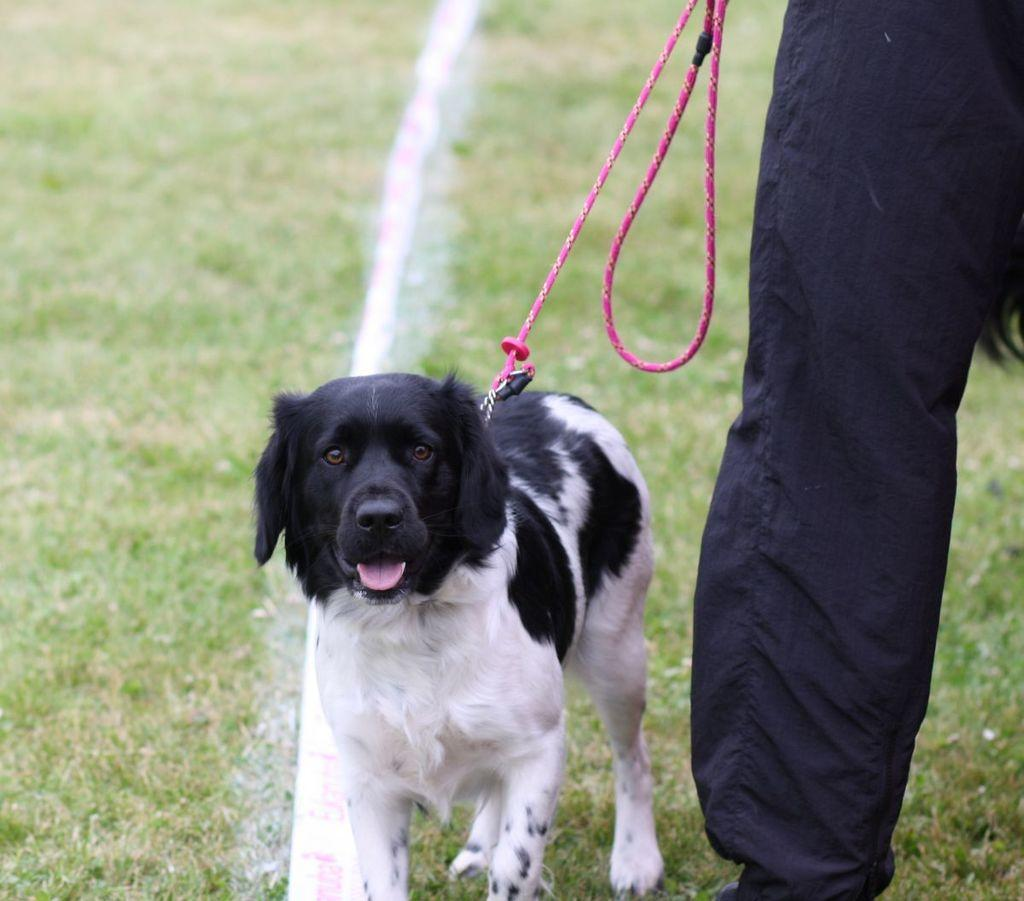What part of a person can be seen in the image? There is a person's leg in the image. What animal is present in the image? There is a dog in the image. What object can be seen in the image? There is a rope in the image. What type of vegetation is visible in the background of the image? The background of the image includes grass. Can you tell me how many goldfish are swimming in the background of the image? There are no goldfish present in the image; the background includes grass. What type of book is the person reading in the image? There is no book present in the image; it features a person's leg, a dog, a rope, and grass in the background. 